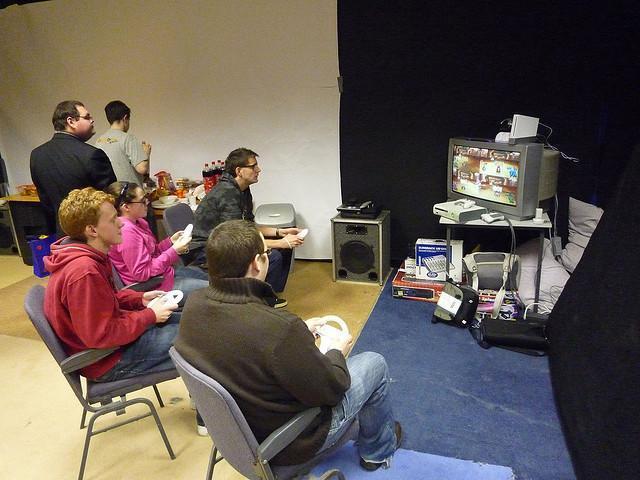How many people are sitting?
Give a very brief answer. 4. How many people are wearing masks?
Give a very brief answer. 0. How many people are in the photo?
Give a very brief answer. 6. How many chairs are in the photo?
Give a very brief answer. 2. How many bears do you see?
Give a very brief answer. 0. 